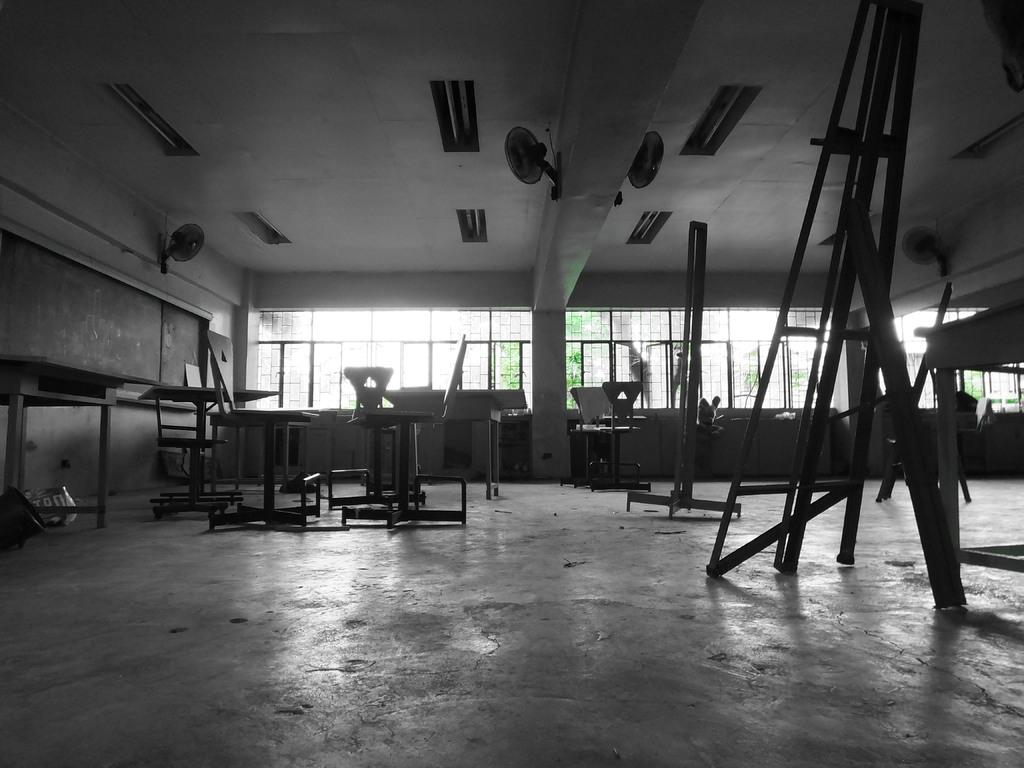What type of furniture is on the floor in the image? There are benches on the floor in the image. What appliances can be seen in the image? Fans are visible in the image. What type of illumination is present in the image? There are lights in the image. What part of the room is visible from the image? The ceiling is visible in the image. What is the purpose of the board in the image? The board in the image might be used for displaying information or announcements. What can be seen through the windows in the image? Trees are visible through the windows in the image. What is the price of the lamp in the image? There is no lamp present in the image, so it is not possible to determine its price. What is the texture of the trees visible through the windows in the image? The texture of the trees cannot be determined from the image alone, as it only provides a visual representation of the trees. 